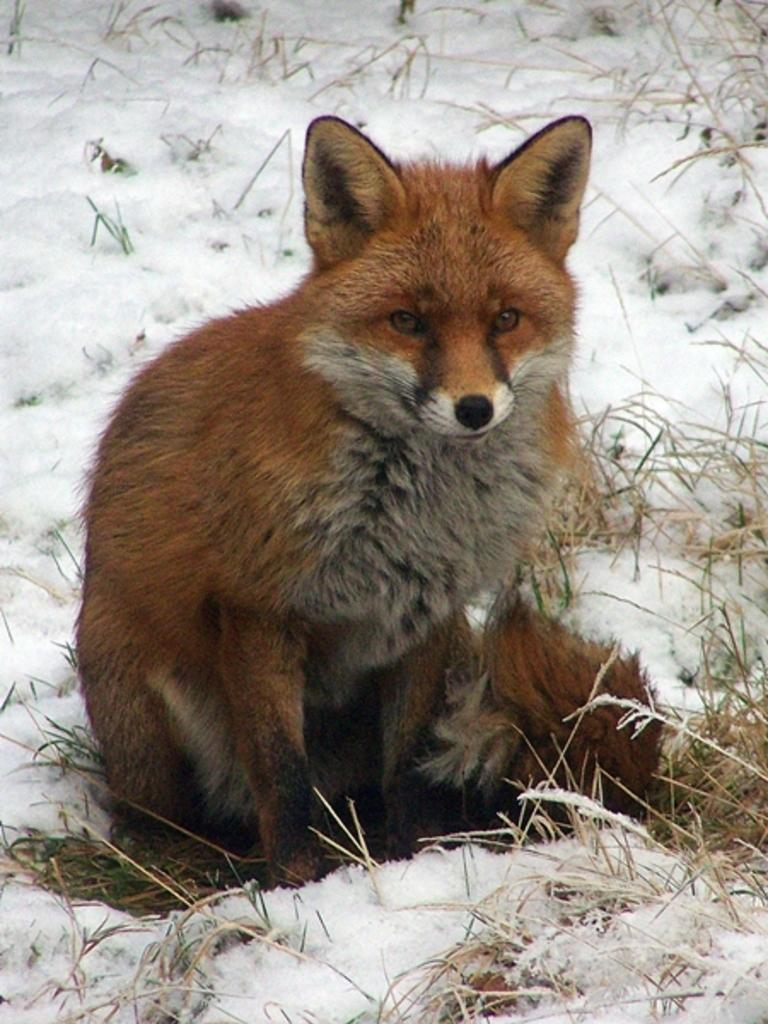What type of animal is in the image? There is a red fox in the image. What is the red fox standing on? The red fox is on the surface of the snow. What type of clothing is the woman wearing in the image? There is no woman present in the image; it features a red fox on the snow. How many snails can be seen crawling on the fox's tail in the image? There are no snails present in the image; it features a red fox on the snow. 